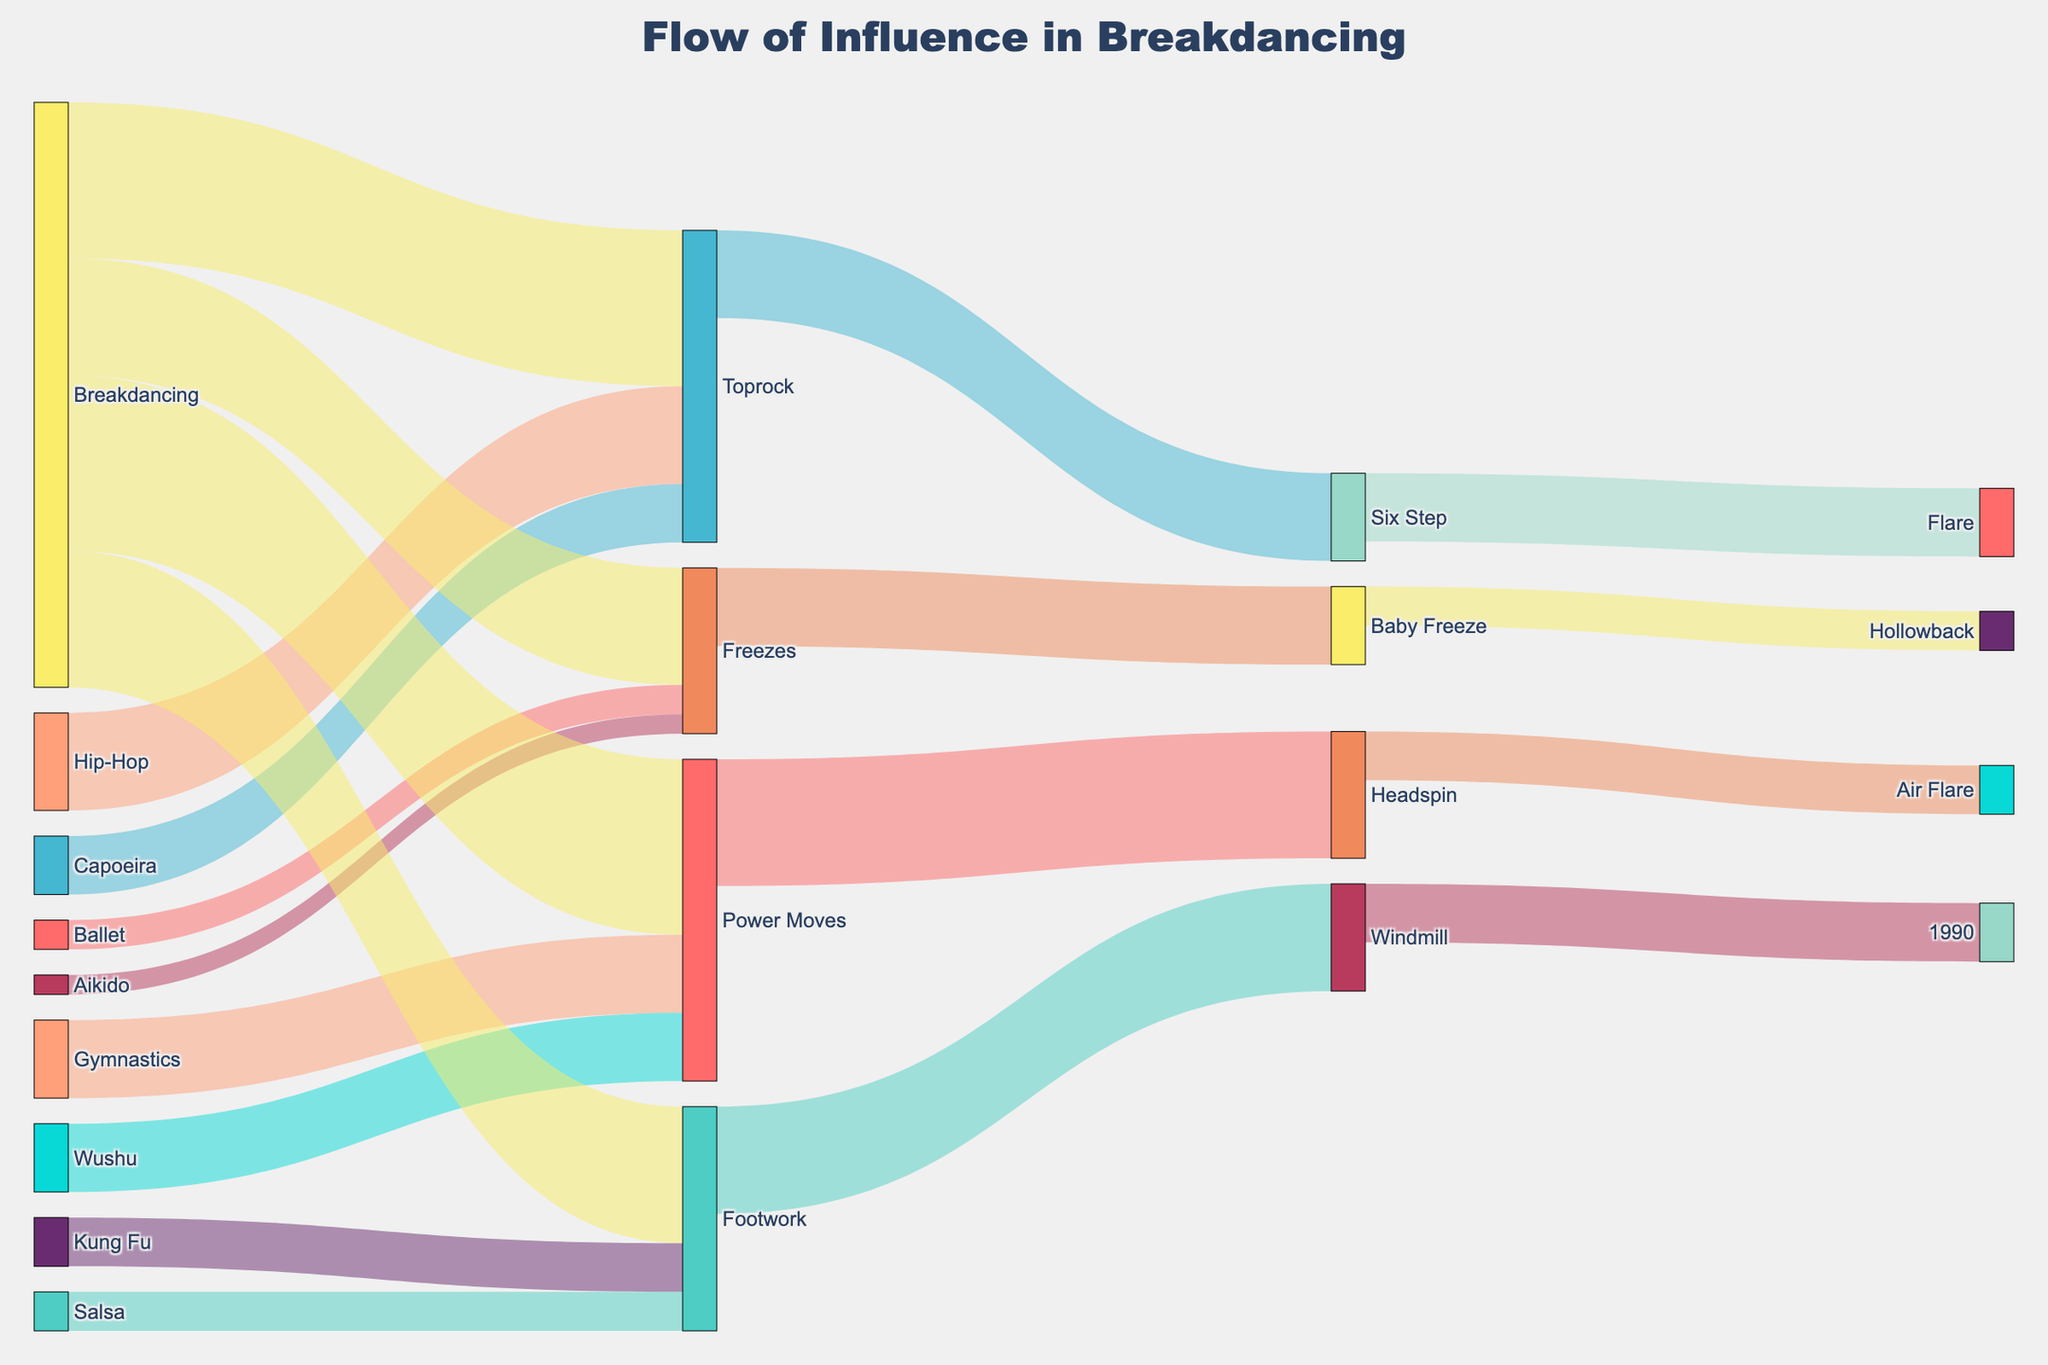What is the title of the Sankey Diagram? Look at the top of the diagram where the title is displayed.
Answer: Flow of Influence in Breakdancing Which source has the highest influence on Footwork? Identify the sources leading to Footwork and compare their values. Kung Fu has 25, and Salsa has 20, making Kung Fu the highest.
Answer: Kung Fu How many different target nodes are shown in the diagram? Count all unique target nodes in the diagram. Targets are: Toprock, Footwork, Power Moves, Freezes, Six Step, Windmill, Headspin, Air Flare, Baby Freeze, Hollowback.
Answer: 10 What is the combined influence from Capoeira and Hip-Hop toward Toprock? Sum the values of Capoeira to Toprock (30) and Hip-Hop to Toprock (50).
Answer: 80 Which dance or martial arts form contributes most significantly to Power Moves? Compare the values leading to Power Moves from Gymnastics (40) and Wushu (35) and note Gymnastics has the higher value.
Answer: Gymnastics How does the influence on Freezes from Aikido compare to Ballet? Compare values from Aikido (10) and Ballet (15) to Freezes. Aikido is less.
Answer: Aikido is less than Ballet Which transition shows the highest connection in the entire diagram? Identify the link with the maximum value. Breakdancing to Power Moves has a value of 90, which is the highest.
Answer: Breakdancing to Power Moves If you sum all influences leading to Power Moves, what would be the total? Add the values of influences to Power Moves: Gymnastics (40), Wushu (35), and Breakdancing (90).
Answer: 165 What is the final target influenced by Headspin? Trace the connection from Headspin and identify its target, which is Air Flare.
Answer: Air Flare Which source contributes the least to the Sankey diagram in total? Calculate total contributions from each source and find the minimum. Aikido contributes 10, which is the smallest overall.
Answer: Aikido 